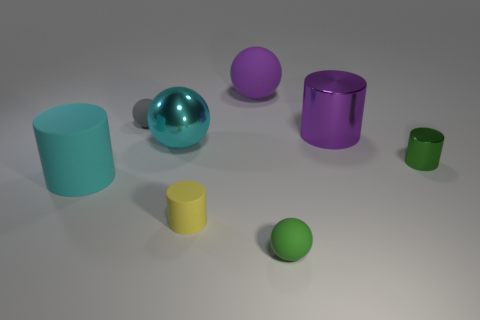Do the big matte sphere and the big shiny cylinder have the same color?
Offer a very short reply. Yes. The green ball has what size?
Your answer should be compact. Small. There is a tiny ball in front of the tiny cylinder behind the big cyan rubber cylinder; how many green things are on the right side of it?
Provide a succinct answer. 1. The cyan object to the left of the big cyan ball left of the tiny green cylinder is what shape?
Your answer should be compact. Cylinder. There is a green object that is the same shape as the small gray object; what is its size?
Offer a very short reply. Small. What is the color of the tiny metal thing in front of the tiny gray matte sphere?
Your response must be concise. Green. There is a cylinder behind the green thing that is behind the tiny green object on the left side of the big purple metal cylinder; what is it made of?
Ensure brevity in your answer.  Metal. What size is the green object behind the big cylinder left of the green matte sphere?
Give a very brief answer. Small. What is the color of the other small thing that is the same shape as the small yellow thing?
Offer a very short reply. Green. How many other big matte cylinders have the same color as the big matte cylinder?
Offer a very short reply. 0. 